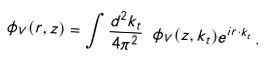Convert formula to latex. <formula><loc_0><loc_0><loc_500><loc_500>\phi _ { V } ( r , z ) = \int \frac { d ^ { 2 } k _ { t } } { 4 \pi ^ { 2 } } \ \phi _ { V } ( z , k _ { t } ) e ^ { i r \cdot k _ { t } } \, .</formula> 